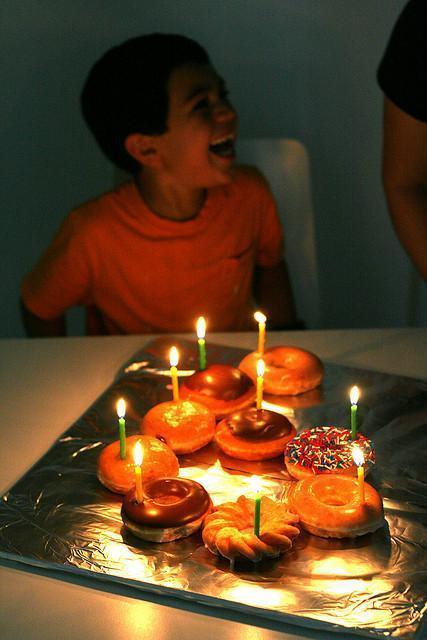How many people are in the photo?
Give a very brief answer. 2. How many donuts are in the photo?
Give a very brief answer. 9. 